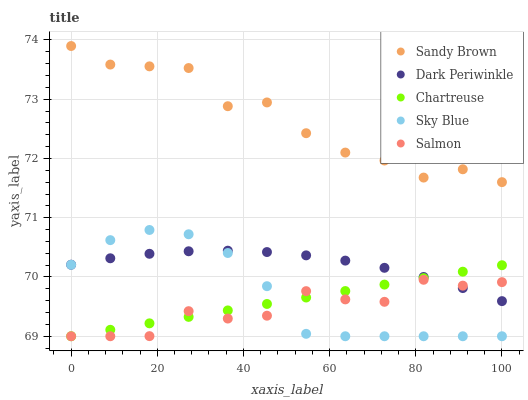Does Salmon have the minimum area under the curve?
Answer yes or no. Yes. Does Sandy Brown have the maximum area under the curve?
Answer yes or no. Yes. Does Chartreuse have the minimum area under the curve?
Answer yes or no. No. Does Chartreuse have the maximum area under the curve?
Answer yes or no. No. Is Chartreuse the smoothest?
Answer yes or no. Yes. Is Sandy Brown the roughest?
Answer yes or no. Yes. Is Sandy Brown the smoothest?
Answer yes or no. No. Is Chartreuse the roughest?
Answer yes or no. No. Does Sky Blue have the lowest value?
Answer yes or no. Yes. Does Sandy Brown have the lowest value?
Answer yes or no. No. Does Sandy Brown have the highest value?
Answer yes or no. Yes. Does Chartreuse have the highest value?
Answer yes or no. No. Is Chartreuse less than Sandy Brown?
Answer yes or no. Yes. Is Sandy Brown greater than Sky Blue?
Answer yes or no. Yes. Does Sky Blue intersect Salmon?
Answer yes or no. Yes. Is Sky Blue less than Salmon?
Answer yes or no. No. Is Sky Blue greater than Salmon?
Answer yes or no. No. Does Chartreuse intersect Sandy Brown?
Answer yes or no. No. 